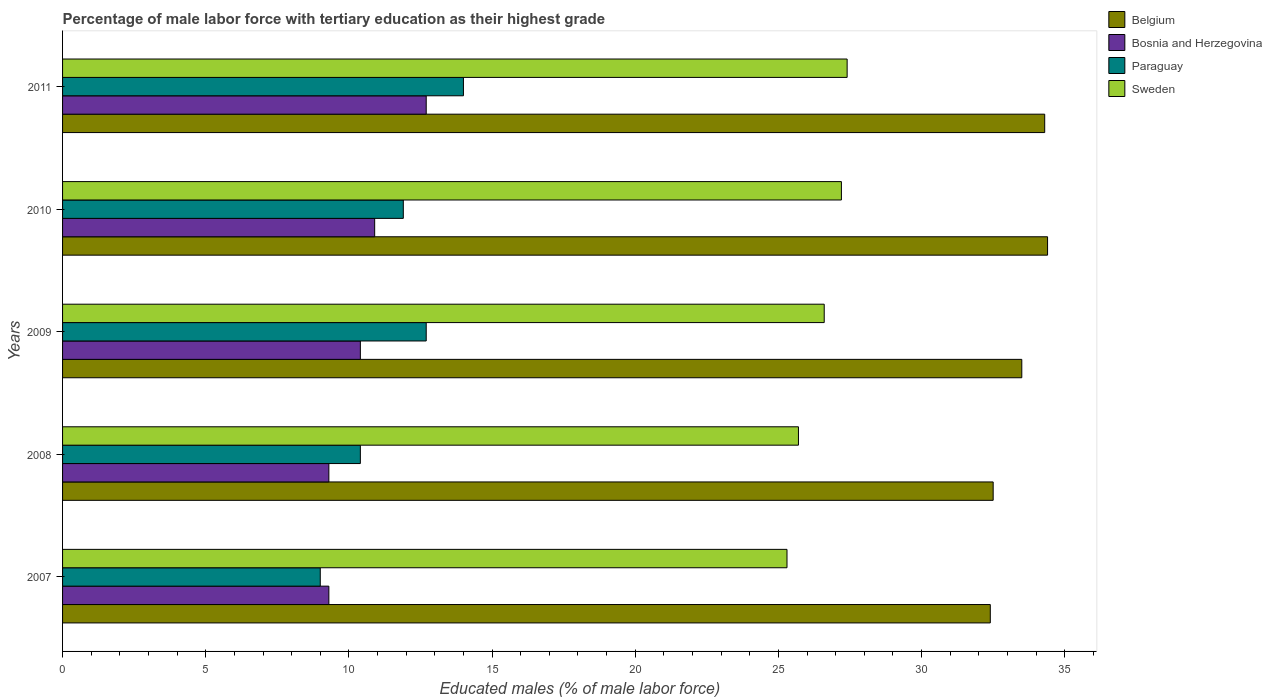How many different coloured bars are there?
Give a very brief answer. 4. How many groups of bars are there?
Ensure brevity in your answer.  5. Are the number of bars per tick equal to the number of legend labels?
Keep it short and to the point. Yes. Are the number of bars on each tick of the Y-axis equal?
Your answer should be very brief. Yes. How many bars are there on the 5th tick from the top?
Your answer should be very brief. 4. How many bars are there on the 5th tick from the bottom?
Provide a short and direct response. 4. What is the label of the 2nd group of bars from the top?
Offer a very short reply. 2010. In how many cases, is the number of bars for a given year not equal to the number of legend labels?
Offer a very short reply. 0. What is the percentage of male labor force with tertiary education in Sweden in 2009?
Give a very brief answer. 26.6. Across all years, what is the maximum percentage of male labor force with tertiary education in Belgium?
Make the answer very short. 34.4. Across all years, what is the minimum percentage of male labor force with tertiary education in Sweden?
Give a very brief answer. 25.3. In which year was the percentage of male labor force with tertiary education in Sweden minimum?
Ensure brevity in your answer.  2007. What is the total percentage of male labor force with tertiary education in Belgium in the graph?
Give a very brief answer. 167.1. What is the difference between the percentage of male labor force with tertiary education in Belgium in 2008 and that in 2010?
Offer a very short reply. -1.9. What is the difference between the percentage of male labor force with tertiary education in Sweden in 2010 and the percentage of male labor force with tertiary education in Bosnia and Herzegovina in 2009?
Offer a terse response. 16.8. What is the average percentage of male labor force with tertiary education in Belgium per year?
Your response must be concise. 33.42. In the year 2009, what is the difference between the percentage of male labor force with tertiary education in Bosnia and Herzegovina and percentage of male labor force with tertiary education in Paraguay?
Keep it short and to the point. -2.3. In how many years, is the percentage of male labor force with tertiary education in Paraguay greater than 22 %?
Your response must be concise. 0. What is the ratio of the percentage of male labor force with tertiary education in Sweden in 2009 to that in 2011?
Provide a succinct answer. 0.97. Is the difference between the percentage of male labor force with tertiary education in Bosnia and Herzegovina in 2007 and 2011 greater than the difference between the percentage of male labor force with tertiary education in Paraguay in 2007 and 2011?
Offer a terse response. Yes. What is the difference between the highest and the second highest percentage of male labor force with tertiary education in Bosnia and Herzegovina?
Your answer should be compact. 1.8. What is the difference between the highest and the lowest percentage of male labor force with tertiary education in Paraguay?
Ensure brevity in your answer.  5. Is the sum of the percentage of male labor force with tertiary education in Paraguay in 2007 and 2010 greater than the maximum percentage of male labor force with tertiary education in Sweden across all years?
Offer a terse response. No. Is it the case that in every year, the sum of the percentage of male labor force with tertiary education in Bosnia and Herzegovina and percentage of male labor force with tertiary education in Paraguay is greater than the sum of percentage of male labor force with tertiary education in Belgium and percentage of male labor force with tertiary education in Sweden?
Offer a terse response. No. What does the 2nd bar from the top in 2009 represents?
Give a very brief answer. Paraguay. What does the 3rd bar from the bottom in 2011 represents?
Give a very brief answer. Paraguay. Are all the bars in the graph horizontal?
Your answer should be compact. Yes. Are the values on the major ticks of X-axis written in scientific E-notation?
Offer a terse response. No. Where does the legend appear in the graph?
Keep it short and to the point. Top right. What is the title of the graph?
Ensure brevity in your answer.  Percentage of male labor force with tertiary education as their highest grade. Does "Turkey" appear as one of the legend labels in the graph?
Your answer should be compact. No. What is the label or title of the X-axis?
Make the answer very short. Educated males (% of male labor force). What is the Educated males (% of male labor force) of Belgium in 2007?
Provide a succinct answer. 32.4. What is the Educated males (% of male labor force) in Bosnia and Herzegovina in 2007?
Offer a terse response. 9.3. What is the Educated males (% of male labor force) of Sweden in 2007?
Offer a very short reply. 25.3. What is the Educated males (% of male labor force) in Belgium in 2008?
Give a very brief answer. 32.5. What is the Educated males (% of male labor force) of Bosnia and Herzegovina in 2008?
Your response must be concise. 9.3. What is the Educated males (% of male labor force) in Paraguay in 2008?
Your answer should be very brief. 10.4. What is the Educated males (% of male labor force) in Sweden in 2008?
Keep it short and to the point. 25.7. What is the Educated males (% of male labor force) in Belgium in 2009?
Your answer should be very brief. 33.5. What is the Educated males (% of male labor force) in Bosnia and Herzegovina in 2009?
Provide a short and direct response. 10.4. What is the Educated males (% of male labor force) in Paraguay in 2009?
Ensure brevity in your answer.  12.7. What is the Educated males (% of male labor force) in Sweden in 2009?
Offer a terse response. 26.6. What is the Educated males (% of male labor force) in Belgium in 2010?
Give a very brief answer. 34.4. What is the Educated males (% of male labor force) of Bosnia and Herzegovina in 2010?
Offer a very short reply. 10.9. What is the Educated males (% of male labor force) in Paraguay in 2010?
Keep it short and to the point. 11.9. What is the Educated males (% of male labor force) in Sweden in 2010?
Keep it short and to the point. 27.2. What is the Educated males (% of male labor force) of Belgium in 2011?
Offer a terse response. 34.3. What is the Educated males (% of male labor force) in Bosnia and Herzegovina in 2011?
Make the answer very short. 12.7. What is the Educated males (% of male labor force) of Paraguay in 2011?
Your answer should be compact. 14. What is the Educated males (% of male labor force) in Sweden in 2011?
Keep it short and to the point. 27.4. Across all years, what is the maximum Educated males (% of male labor force) in Belgium?
Ensure brevity in your answer.  34.4. Across all years, what is the maximum Educated males (% of male labor force) of Bosnia and Herzegovina?
Your answer should be very brief. 12.7. Across all years, what is the maximum Educated males (% of male labor force) of Sweden?
Provide a short and direct response. 27.4. Across all years, what is the minimum Educated males (% of male labor force) of Belgium?
Your answer should be compact. 32.4. Across all years, what is the minimum Educated males (% of male labor force) in Bosnia and Herzegovina?
Offer a terse response. 9.3. Across all years, what is the minimum Educated males (% of male labor force) in Sweden?
Provide a succinct answer. 25.3. What is the total Educated males (% of male labor force) of Belgium in the graph?
Provide a succinct answer. 167.1. What is the total Educated males (% of male labor force) of Bosnia and Herzegovina in the graph?
Give a very brief answer. 52.6. What is the total Educated males (% of male labor force) of Sweden in the graph?
Make the answer very short. 132.2. What is the difference between the Educated males (% of male labor force) of Paraguay in 2007 and that in 2008?
Provide a succinct answer. -1.4. What is the difference between the Educated males (% of male labor force) of Belgium in 2007 and that in 2009?
Make the answer very short. -1.1. What is the difference between the Educated males (% of male labor force) in Bosnia and Herzegovina in 2007 and that in 2009?
Your answer should be very brief. -1.1. What is the difference between the Educated males (% of male labor force) of Paraguay in 2007 and that in 2009?
Ensure brevity in your answer.  -3.7. What is the difference between the Educated males (% of male labor force) of Sweden in 2007 and that in 2009?
Your answer should be very brief. -1.3. What is the difference between the Educated males (% of male labor force) of Belgium in 2007 and that in 2010?
Give a very brief answer. -2. What is the difference between the Educated males (% of male labor force) of Bosnia and Herzegovina in 2007 and that in 2010?
Keep it short and to the point. -1.6. What is the difference between the Educated males (% of male labor force) of Paraguay in 2007 and that in 2010?
Provide a short and direct response. -2.9. What is the difference between the Educated males (% of male labor force) in Paraguay in 2007 and that in 2011?
Make the answer very short. -5. What is the difference between the Educated males (% of male labor force) in Paraguay in 2008 and that in 2009?
Provide a succinct answer. -2.3. What is the difference between the Educated males (% of male labor force) of Belgium in 2008 and that in 2010?
Keep it short and to the point. -1.9. What is the difference between the Educated males (% of male labor force) of Bosnia and Herzegovina in 2008 and that in 2010?
Make the answer very short. -1.6. What is the difference between the Educated males (% of male labor force) in Sweden in 2008 and that in 2010?
Provide a short and direct response. -1.5. What is the difference between the Educated males (% of male labor force) of Paraguay in 2008 and that in 2011?
Your answer should be compact. -3.6. What is the difference between the Educated males (% of male labor force) in Bosnia and Herzegovina in 2009 and that in 2010?
Offer a very short reply. -0.5. What is the difference between the Educated males (% of male labor force) of Paraguay in 2009 and that in 2010?
Your response must be concise. 0.8. What is the difference between the Educated males (% of male labor force) in Sweden in 2009 and that in 2010?
Ensure brevity in your answer.  -0.6. What is the difference between the Educated males (% of male labor force) in Belgium in 2009 and that in 2011?
Keep it short and to the point. -0.8. What is the difference between the Educated males (% of male labor force) of Bosnia and Herzegovina in 2009 and that in 2011?
Your response must be concise. -2.3. What is the difference between the Educated males (% of male labor force) in Sweden in 2009 and that in 2011?
Your response must be concise. -0.8. What is the difference between the Educated males (% of male labor force) in Bosnia and Herzegovina in 2010 and that in 2011?
Your answer should be compact. -1.8. What is the difference between the Educated males (% of male labor force) of Belgium in 2007 and the Educated males (% of male labor force) of Bosnia and Herzegovina in 2008?
Offer a terse response. 23.1. What is the difference between the Educated males (% of male labor force) in Belgium in 2007 and the Educated males (% of male labor force) in Sweden in 2008?
Provide a short and direct response. 6.7. What is the difference between the Educated males (% of male labor force) in Bosnia and Herzegovina in 2007 and the Educated males (% of male labor force) in Sweden in 2008?
Provide a succinct answer. -16.4. What is the difference between the Educated males (% of male labor force) of Paraguay in 2007 and the Educated males (% of male labor force) of Sweden in 2008?
Offer a very short reply. -16.7. What is the difference between the Educated males (% of male labor force) of Belgium in 2007 and the Educated males (% of male labor force) of Bosnia and Herzegovina in 2009?
Give a very brief answer. 22. What is the difference between the Educated males (% of male labor force) of Belgium in 2007 and the Educated males (% of male labor force) of Paraguay in 2009?
Keep it short and to the point. 19.7. What is the difference between the Educated males (% of male labor force) of Belgium in 2007 and the Educated males (% of male labor force) of Sweden in 2009?
Ensure brevity in your answer.  5.8. What is the difference between the Educated males (% of male labor force) of Bosnia and Herzegovina in 2007 and the Educated males (% of male labor force) of Sweden in 2009?
Offer a very short reply. -17.3. What is the difference between the Educated males (% of male labor force) in Paraguay in 2007 and the Educated males (% of male labor force) in Sweden in 2009?
Offer a very short reply. -17.6. What is the difference between the Educated males (% of male labor force) of Belgium in 2007 and the Educated males (% of male labor force) of Bosnia and Herzegovina in 2010?
Give a very brief answer. 21.5. What is the difference between the Educated males (% of male labor force) in Belgium in 2007 and the Educated males (% of male labor force) in Paraguay in 2010?
Offer a very short reply. 20.5. What is the difference between the Educated males (% of male labor force) of Bosnia and Herzegovina in 2007 and the Educated males (% of male labor force) of Sweden in 2010?
Provide a succinct answer. -17.9. What is the difference between the Educated males (% of male labor force) of Paraguay in 2007 and the Educated males (% of male labor force) of Sweden in 2010?
Give a very brief answer. -18.2. What is the difference between the Educated males (% of male labor force) in Belgium in 2007 and the Educated males (% of male labor force) in Bosnia and Herzegovina in 2011?
Your answer should be very brief. 19.7. What is the difference between the Educated males (% of male labor force) of Bosnia and Herzegovina in 2007 and the Educated males (% of male labor force) of Sweden in 2011?
Offer a very short reply. -18.1. What is the difference between the Educated males (% of male labor force) in Paraguay in 2007 and the Educated males (% of male labor force) in Sweden in 2011?
Your answer should be compact. -18.4. What is the difference between the Educated males (% of male labor force) of Belgium in 2008 and the Educated males (% of male labor force) of Bosnia and Herzegovina in 2009?
Keep it short and to the point. 22.1. What is the difference between the Educated males (% of male labor force) in Belgium in 2008 and the Educated males (% of male labor force) in Paraguay in 2009?
Your answer should be very brief. 19.8. What is the difference between the Educated males (% of male labor force) in Belgium in 2008 and the Educated males (% of male labor force) in Sweden in 2009?
Offer a very short reply. 5.9. What is the difference between the Educated males (% of male labor force) in Bosnia and Herzegovina in 2008 and the Educated males (% of male labor force) in Paraguay in 2009?
Your response must be concise. -3.4. What is the difference between the Educated males (% of male labor force) in Bosnia and Herzegovina in 2008 and the Educated males (% of male labor force) in Sweden in 2009?
Make the answer very short. -17.3. What is the difference between the Educated males (% of male labor force) of Paraguay in 2008 and the Educated males (% of male labor force) of Sweden in 2009?
Your response must be concise. -16.2. What is the difference between the Educated males (% of male labor force) in Belgium in 2008 and the Educated males (% of male labor force) in Bosnia and Herzegovina in 2010?
Offer a very short reply. 21.6. What is the difference between the Educated males (% of male labor force) in Belgium in 2008 and the Educated males (% of male labor force) in Paraguay in 2010?
Provide a short and direct response. 20.6. What is the difference between the Educated males (% of male labor force) of Bosnia and Herzegovina in 2008 and the Educated males (% of male labor force) of Sweden in 2010?
Your answer should be compact. -17.9. What is the difference between the Educated males (% of male labor force) in Paraguay in 2008 and the Educated males (% of male labor force) in Sweden in 2010?
Offer a very short reply. -16.8. What is the difference between the Educated males (% of male labor force) in Belgium in 2008 and the Educated males (% of male labor force) in Bosnia and Herzegovina in 2011?
Give a very brief answer. 19.8. What is the difference between the Educated males (% of male labor force) of Bosnia and Herzegovina in 2008 and the Educated males (% of male labor force) of Sweden in 2011?
Make the answer very short. -18.1. What is the difference between the Educated males (% of male labor force) of Belgium in 2009 and the Educated males (% of male labor force) of Bosnia and Herzegovina in 2010?
Give a very brief answer. 22.6. What is the difference between the Educated males (% of male labor force) of Belgium in 2009 and the Educated males (% of male labor force) of Paraguay in 2010?
Offer a very short reply. 21.6. What is the difference between the Educated males (% of male labor force) of Bosnia and Herzegovina in 2009 and the Educated males (% of male labor force) of Paraguay in 2010?
Your response must be concise. -1.5. What is the difference between the Educated males (% of male labor force) in Bosnia and Herzegovina in 2009 and the Educated males (% of male labor force) in Sweden in 2010?
Your answer should be compact. -16.8. What is the difference between the Educated males (% of male labor force) in Belgium in 2009 and the Educated males (% of male labor force) in Bosnia and Herzegovina in 2011?
Provide a short and direct response. 20.8. What is the difference between the Educated males (% of male labor force) in Paraguay in 2009 and the Educated males (% of male labor force) in Sweden in 2011?
Provide a succinct answer. -14.7. What is the difference between the Educated males (% of male labor force) of Belgium in 2010 and the Educated males (% of male labor force) of Bosnia and Herzegovina in 2011?
Offer a very short reply. 21.7. What is the difference between the Educated males (% of male labor force) in Belgium in 2010 and the Educated males (% of male labor force) in Paraguay in 2011?
Give a very brief answer. 20.4. What is the difference between the Educated males (% of male labor force) of Bosnia and Herzegovina in 2010 and the Educated males (% of male labor force) of Paraguay in 2011?
Ensure brevity in your answer.  -3.1. What is the difference between the Educated males (% of male labor force) in Bosnia and Herzegovina in 2010 and the Educated males (% of male labor force) in Sweden in 2011?
Give a very brief answer. -16.5. What is the difference between the Educated males (% of male labor force) in Paraguay in 2010 and the Educated males (% of male labor force) in Sweden in 2011?
Keep it short and to the point. -15.5. What is the average Educated males (% of male labor force) in Belgium per year?
Keep it short and to the point. 33.42. What is the average Educated males (% of male labor force) of Bosnia and Herzegovina per year?
Your answer should be compact. 10.52. What is the average Educated males (% of male labor force) in Paraguay per year?
Make the answer very short. 11.6. What is the average Educated males (% of male labor force) of Sweden per year?
Provide a succinct answer. 26.44. In the year 2007, what is the difference between the Educated males (% of male labor force) of Belgium and Educated males (% of male labor force) of Bosnia and Herzegovina?
Provide a succinct answer. 23.1. In the year 2007, what is the difference between the Educated males (% of male labor force) in Belgium and Educated males (% of male labor force) in Paraguay?
Make the answer very short. 23.4. In the year 2007, what is the difference between the Educated males (% of male labor force) in Belgium and Educated males (% of male labor force) in Sweden?
Make the answer very short. 7.1. In the year 2007, what is the difference between the Educated males (% of male labor force) in Bosnia and Herzegovina and Educated males (% of male labor force) in Paraguay?
Keep it short and to the point. 0.3. In the year 2007, what is the difference between the Educated males (% of male labor force) in Paraguay and Educated males (% of male labor force) in Sweden?
Give a very brief answer. -16.3. In the year 2008, what is the difference between the Educated males (% of male labor force) in Belgium and Educated males (% of male labor force) in Bosnia and Herzegovina?
Make the answer very short. 23.2. In the year 2008, what is the difference between the Educated males (% of male labor force) of Belgium and Educated males (% of male labor force) of Paraguay?
Keep it short and to the point. 22.1. In the year 2008, what is the difference between the Educated males (% of male labor force) in Belgium and Educated males (% of male labor force) in Sweden?
Offer a terse response. 6.8. In the year 2008, what is the difference between the Educated males (% of male labor force) in Bosnia and Herzegovina and Educated males (% of male labor force) in Paraguay?
Offer a very short reply. -1.1. In the year 2008, what is the difference between the Educated males (% of male labor force) in Bosnia and Herzegovina and Educated males (% of male labor force) in Sweden?
Offer a very short reply. -16.4. In the year 2008, what is the difference between the Educated males (% of male labor force) of Paraguay and Educated males (% of male labor force) of Sweden?
Give a very brief answer. -15.3. In the year 2009, what is the difference between the Educated males (% of male labor force) of Belgium and Educated males (% of male labor force) of Bosnia and Herzegovina?
Keep it short and to the point. 23.1. In the year 2009, what is the difference between the Educated males (% of male labor force) of Belgium and Educated males (% of male labor force) of Paraguay?
Give a very brief answer. 20.8. In the year 2009, what is the difference between the Educated males (% of male labor force) in Belgium and Educated males (% of male labor force) in Sweden?
Your response must be concise. 6.9. In the year 2009, what is the difference between the Educated males (% of male labor force) of Bosnia and Herzegovina and Educated males (% of male labor force) of Sweden?
Provide a succinct answer. -16.2. In the year 2009, what is the difference between the Educated males (% of male labor force) of Paraguay and Educated males (% of male labor force) of Sweden?
Your answer should be very brief. -13.9. In the year 2010, what is the difference between the Educated males (% of male labor force) in Belgium and Educated males (% of male labor force) in Paraguay?
Keep it short and to the point. 22.5. In the year 2010, what is the difference between the Educated males (% of male labor force) of Bosnia and Herzegovina and Educated males (% of male labor force) of Paraguay?
Make the answer very short. -1. In the year 2010, what is the difference between the Educated males (% of male labor force) in Bosnia and Herzegovina and Educated males (% of male labor force) in Sweden?
Keep it short and to the point. -16.3. In the year 2010, what is the difference between the Educated males (% of male labor force) in Paraguay and Educated males (% of male labor force) in Sweden?
Your answer should be very brief. -15.3. In the year 2011, what is the difference between the Educated males (% of male labor force) of Belgium and Educated males (% of male labor force) of Bosnia and Herzegovina?
Your answer should be compact. 21.6. In the year 2011, what is the difference between the Educated males (% of male labor force) in Belgium and Educated males (% of male labor force) in Paraguay?
Provide a succinct answer. 20.3. In the year 2011, what is the difference between the Educated males (% of male labor force) in Belgium and Educated males (% of male labor force) in Sweden?
Make the answer very short. 6.9. In the year 2011, what is the difference between the Educated males (% of male labor force) in Bosnia and Herzegovina and Educated males (% of male labor force) in Paraguay?
Offer a terse response. -1.3. In the year 2011, what is the difference between the Educated males (% of male labor force) in Bosnia and Herzegovina and Educated males (% of male labor force) in Sweden?
Provide a short and direct response. -14.7. What is the ratio of the Educated males (% of male labor force) of Belgium in 2007 to that in 2008?
Make the answer very short. 1. What is the ratio of the Educated males (% of male labor force) of Paraguay in 2007 to that in 2008?
Provide a short and direct response. 0.87. What is the ratio of the Educated males (% of male labor force) in Sweden in 2007 to that in 2008?
Give a very brief answer. 0.98. What is the ratio of the Educated males (% of male labor force) in Belgium in 2007 to that in 2009?
Your response must be concise. 0.97. What is the ratio of the Educated males (% of male labor force) of Bosnia and Herzegovina in 2007 to that in 2009?
Your response must be concise. 0.89. What is the ratio of the Educated males (% of male labor force) of Paraguay in 2007 to that in 2009?
Offer a terse response. 0.71. What is the ratio of the Educated males (% of male labor force) in Sweden in 2007 to that in 2009?
Provide a succinct answer. 0.95. What is the ratio of the Educated males (% of male labor force) of Belgium in 2007 to that in 2010?
Your answer should be very brief. 0.94. What is the ratio of the Educated males (% of male labor force) of Bosnia and Herzegovina in 2007 to that in 2010?
Provide a short and direct response. 0.85. What is the ratio of the Educated males (% of male labor force) of Paraguay in 2007 to that in 2010?
Your answer should be compact. 0.76. What is the ratio of the Educated males (% of male labor force) in Sweden in 2007 to that in 2010?
Offer a very short reply. 0.93. What is the ratio of the Educated males (% of male labor force) in Belgium in 2007 to that in 2011?
Your response must be concise. 0.94. What is the ratio of the Educated males (% of male labor force) in Bosnia and Herzegovina in 2007 to that in 2011?
Your response must be concise. 0.73. What is the ratio of the Educated males (% of male labor force) of Paraguay in 2007 to that in 2011?
Your response must be concise. 0.64. What is the ratio of the Educated males (% of male labor force) in Sweden in 2007 to that in 2011?
Ensure brevity in your answer.  0.92. What is the ratio of the Educated males (% of male labor force) of Belgium in 2008 to that in 2009?
Provide a succinct answer. 0.97. What is the ratio of the Educated males (% of male labor force) in Bosnia and Herzegovina in 2008 to that in 2009?
Keep it short and to the point. 0.89. What is the ratio of the Educated males (% of male labor force) in Paraguay in 2008 to that in 2009?
Provide a succinct answer. 0.82. What is the ratio of the Educated males (% of male labor force) of Sweden in 2008 to that in 2009?
Your response must be concise. 0.97. What is the ratio of the Educated males (% of male labor force) in Belgium in 2008 to that in 2010?
Ensure brevity in your answer.  0.94. What is the ratio of the Educated males (% of male labor force) of Bosnia and Herzegovina in 2008 to that in 2010?
Ensure brevity in your answer.  0.85. What is the ratio of the Educated males (% of male labor force) of Paraguay in 2008 to that in 2010?
Offer a terse response. 0.87. What is the ratio of the Educated males (% of male labor force) of Sweden in 2008 to that in 2010?
Make the answer very short. 0.94. What is the ratio of the Educated males (% of male labor force) of Belgium in 2008 to that in 2011?
Keep it short and to the point. 0.95. What is the ratio of the Educated males (% of male labor force) in Bosnia and Herzegovina in 2008 to that in 2011?
Your answer should be very brief. 0.73. What is the ratio of the Educated males (% of male labor force) of Paraguay in 2008 to that in 2011?
Your answer should be very brief. 0.74. What is the ratio of the Educated males (% of male labor force) of Sweden in 2008 to that in 2011?
Keep it short and to the point. 0.94. What is the ratio of the Educated males (% of male labor force) in Belgium in 2009 to that in 2010?
Your answer should be very brief. 0.97. What is the ratio of the Educated males (% of male labor force) in Bosnia and Herzegovina in 2009 to that in 2010?
Provide a succinct answer. 0.95. What is the ratio of the Educated males (% of male labor force) in Paraguay in 2009 to that in 2010?
Your answer should be very brief. 1.07. What is the ratio of the Educated males (% of male labor force) of Sweden in 2009 to that in 2010?
Make the answer very short. 0.98. What is the ratio of the Educated males (% of male labor force) of Belgium in 2009 to that in 2011?
Your response must be concise. 0.98. What is the ratio of the Educated males (% of male labor force) in Bosnia and Herzegovina in 2009 to that in 2011?
Provide a short and direct response. 0.82. What is the ratio of the Educated males (% of male labor force) in Paraguay in 2009 to that in 2011?
Make the answer very short. 0.91. What is the ratio of the Educated males (% of male labor force) in Sweden in 2009 to that in 2011?
Offer a terse response. 0.97. What is the ratio of the Educated males (% of male labor force) in Belgium in 2010 to that in 2011?
Your response must be concise. 1. What is the ratio of the Educated males (% of male labor force) of Bosnia and Herzegovina in 2010 to that in 2011?
Ensure brevity in your answer.  0.86. What is the ratio of the Educated males (% of male labor force) in Paraguay in 2010 to that in 2011?
Your answer should be very brief. 0.85. What is the ratio of the Educated males (% of male labor force) in Sweden in 2010 to that in 2011?
Offer a very short reply. 0.99. What is the difference between the highest and the second highest Educated males (% of male labor force) of Belgium?
Make the answer very short. 0.1. What is the difference between the highest and the second highest Educated males (% of male labor force) in Paraguay?
Make the answer very short. 1.3. What is the difference between the highest and the lowest Educated males (% of male labor force) of Belgium?
Give a very brief answer. 2. What is the difference between the highest and the lowest Educated males (% of male labor force) in Sweden?
Offer a very short reply. 2.1. 